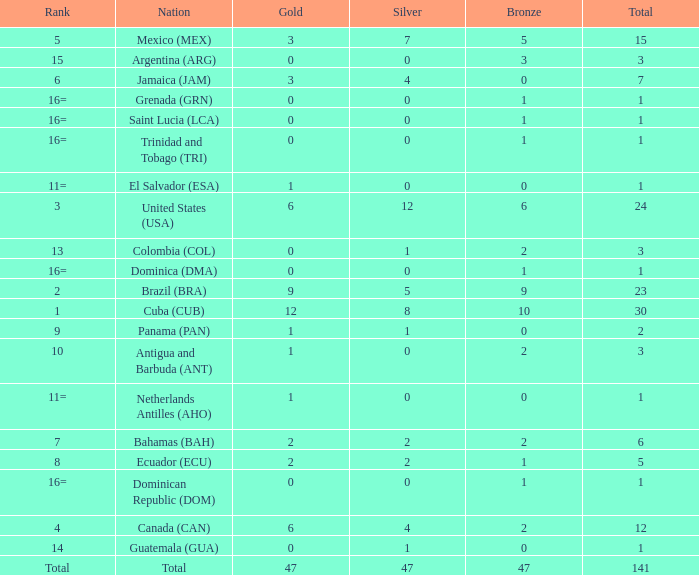What is the total gold with a total less than 1? None. 